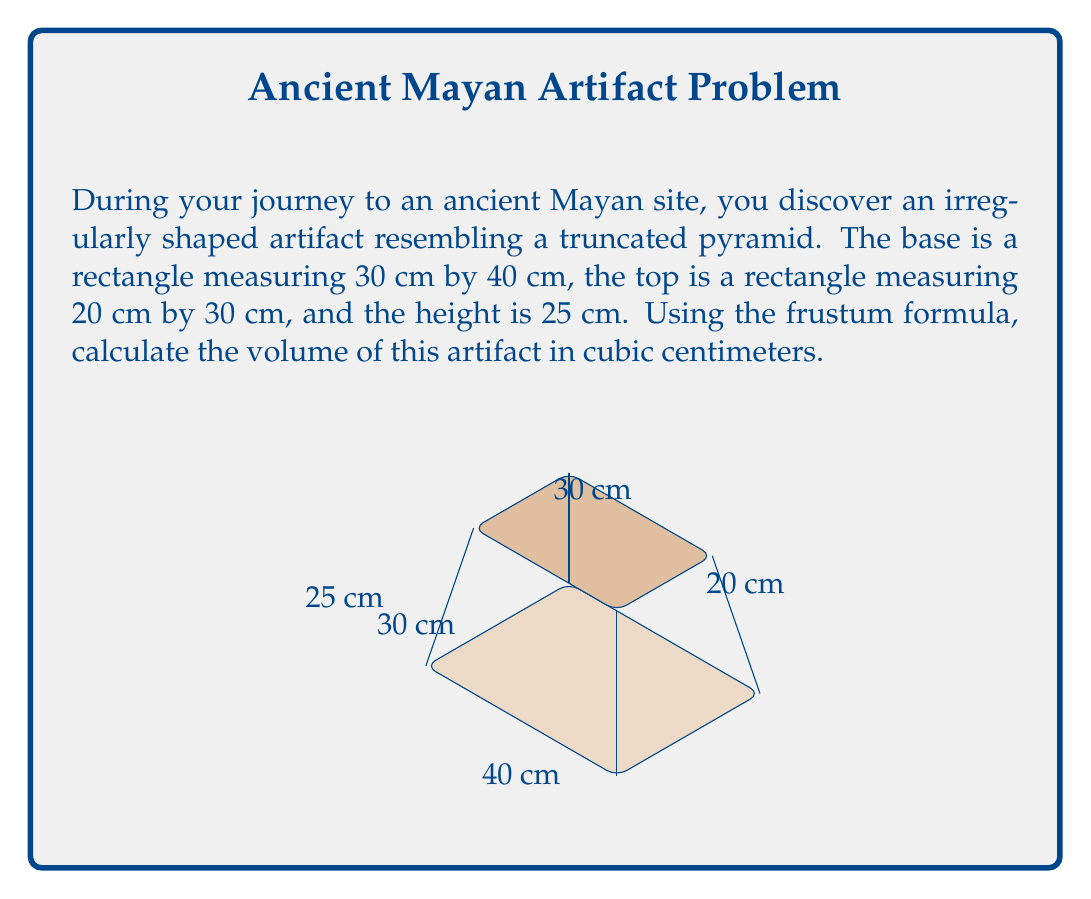Give your solution to this math problem. To solve this problem, we'll use the frustum formula for volume:

$$V = \frac{h}{3}(A_1 + A_2 + \sqrt{A_1A_2})$$

Where:
$V$ = Volume
$h$ = Height
$A_1$ = Area of the base
$A_2$ = Area of the top

Step 1: Calculate the area of the base ($A_1$)
$A_1 = 30 \text{ cm} \times 40 \text{ cm} = 1200 \text{ cm}^2$

Step 2: Calculate the area of the top ($A_2$)
$A_2 = 20 \text{ cm} \times 30 \text{ cm} = 600 \text{ cm}^2$

Step 3: Calculate $\sqrt{A_1A_2}$
$\sqrt{A_1A_2} = \sqrt{1200 \text{ cm}^2 \times 600 \text{ cm}^2} = \sqrt{720000 \text{ cm}^4} = 848.53 \text{ cm}^2$

Step 4: Apply the frustum formula
$V = \frac{25 \text{ cm}}{3}(1200 \text{ cm}^2 + 600 \text{ cm}^2 + 848.53 \text{ cm}^2)$
$V = \frac{25}{3}(2648.53) \text{ cm}^3$
$V = 22071.08 \text{ cm}^3$

Step 5: Round to the nearest whole number
$V \approx 22071 \text{ cm}^3$
Answer: 22071 cm³ 